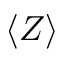<formula> <loc_0><loc_0><loc_500><loc_500>\langle Z \rangle</formula> 